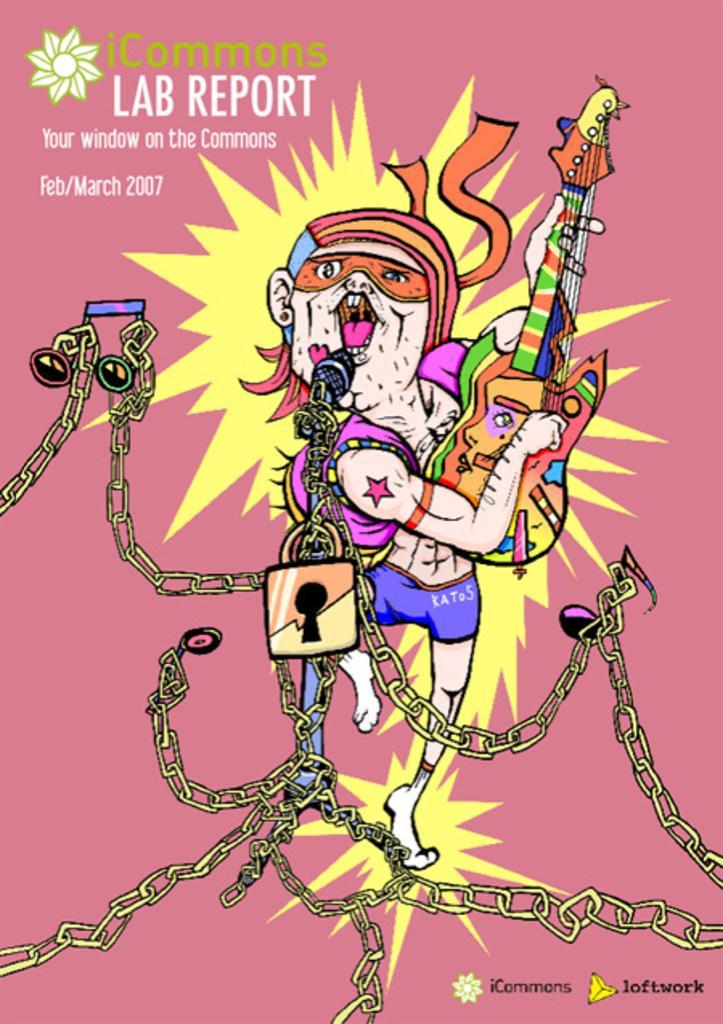Describe this image in one or two sentences. This image consists of a poster on which I can see painting of a person is holding a guitar in the hands and standing. In front of this person there is a mike along with some chains. On the left top of the image I can see some text. 